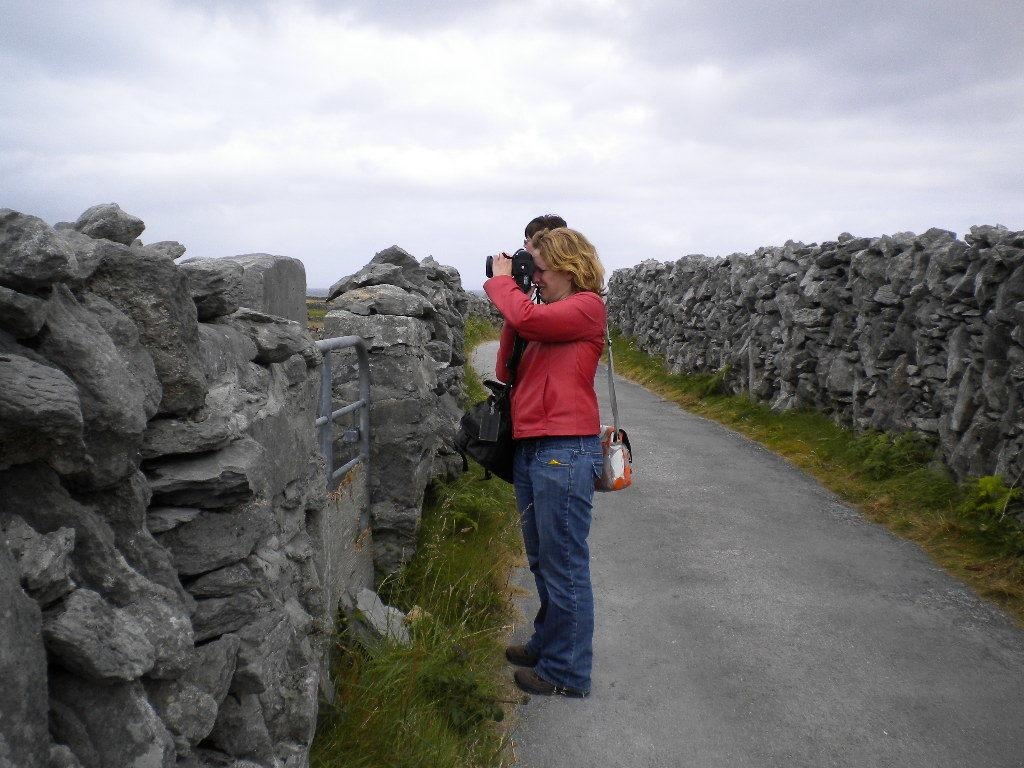Who is present in the image? There is a woman in the image. What is the woman holding? The woman is holding a camera. What type of landscape can be seen in the image? There are rock walls and grass in the image. How would you describe the weather based on the image? The sky is cloudy in the image. What type of coat is the woman wearing in the image? There is no coat visible in the image; the woman is not wearing one. Can you tell me how many pets are present in the image? There are no pets present in the image. 